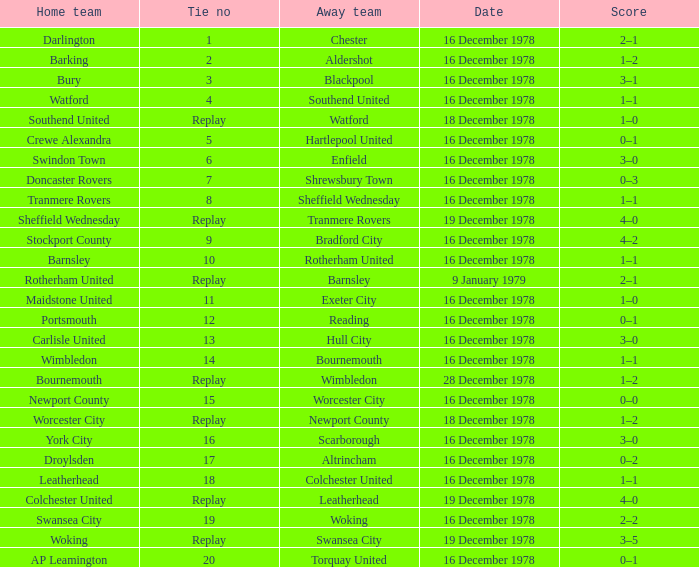Waht was the away team when the home team is colchester united? Leatherhead. 